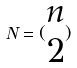Convert formula to latex. <formula><loc_0><loc_0><loc_500><loc_500>N = ( \begin{matrix} n \\ 2 \end{matrix} )</formula> 